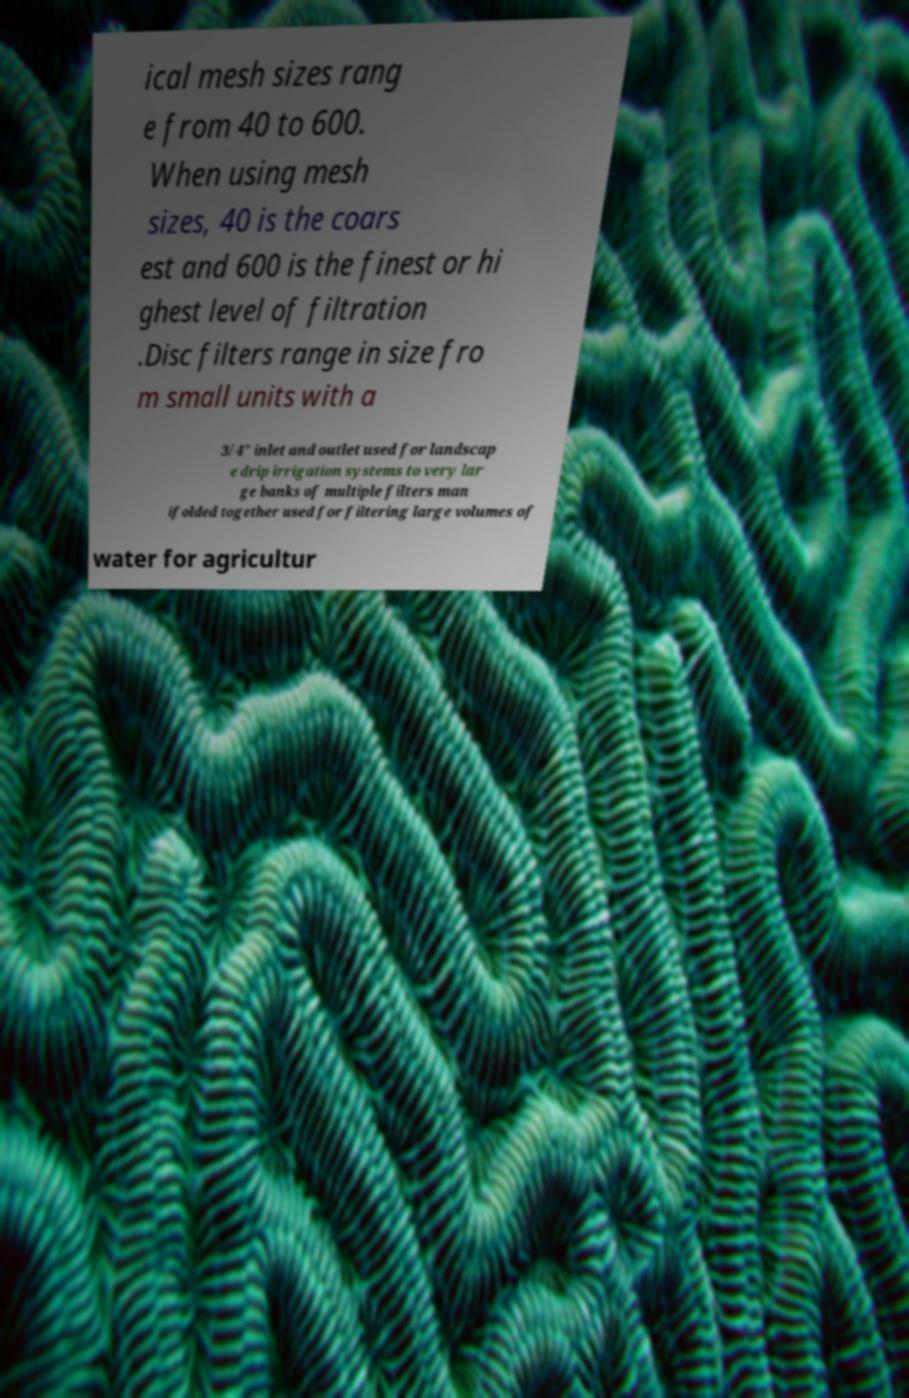Could you extract and type out the text from this image? ical mesh sizes rang e from 40 to 600. When using mesh sizes, 40 is the coars est and 600 is the finest or hi ghest level of filtration .Disc filters range in size fro m small units with a 3/4" inlet and outlet used for landscap e drip irrigation systems to very lar ge banks of multiple filters man ifolded together used for filtering large volumes of water for agricultur 